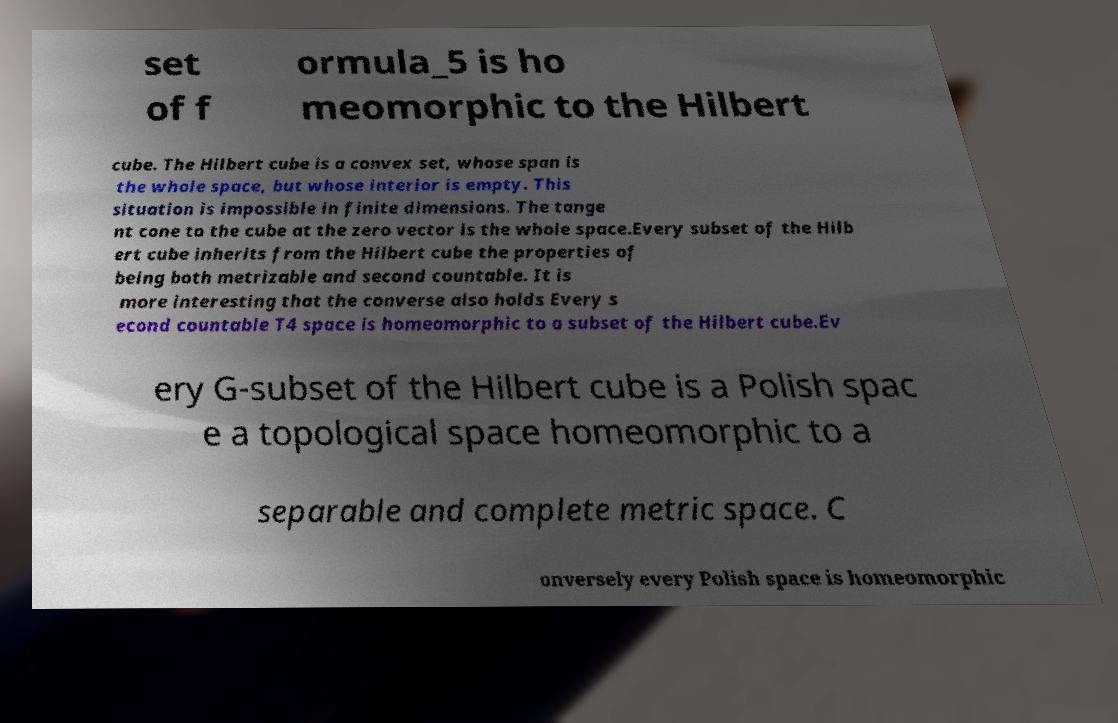Please read and relay the text visible in this image. What does it say? set of f ormula_5 is ho meomorphic to the Hilbert cube. The Hilbert cube is a convex set, whose span is the whole space, but whose interior is empty. This situation is impossible in finite dimensions. The tange nt cone to the cube at the zero vector is the whole space.Every subset of the Hilb ert cube inherits from the Hilbert cube the properties of being both metrizable and second countable. It is more interesting that the converse also holds Every s econd countable T4 space is homeomorphic to a subset of the Hilbert cube.Ev ery G-subset of the Hilbert cube is a Polish spac e a topological space homeomorphic to a separable and complete metric space. C onversely every Polish space is homeomorphic 